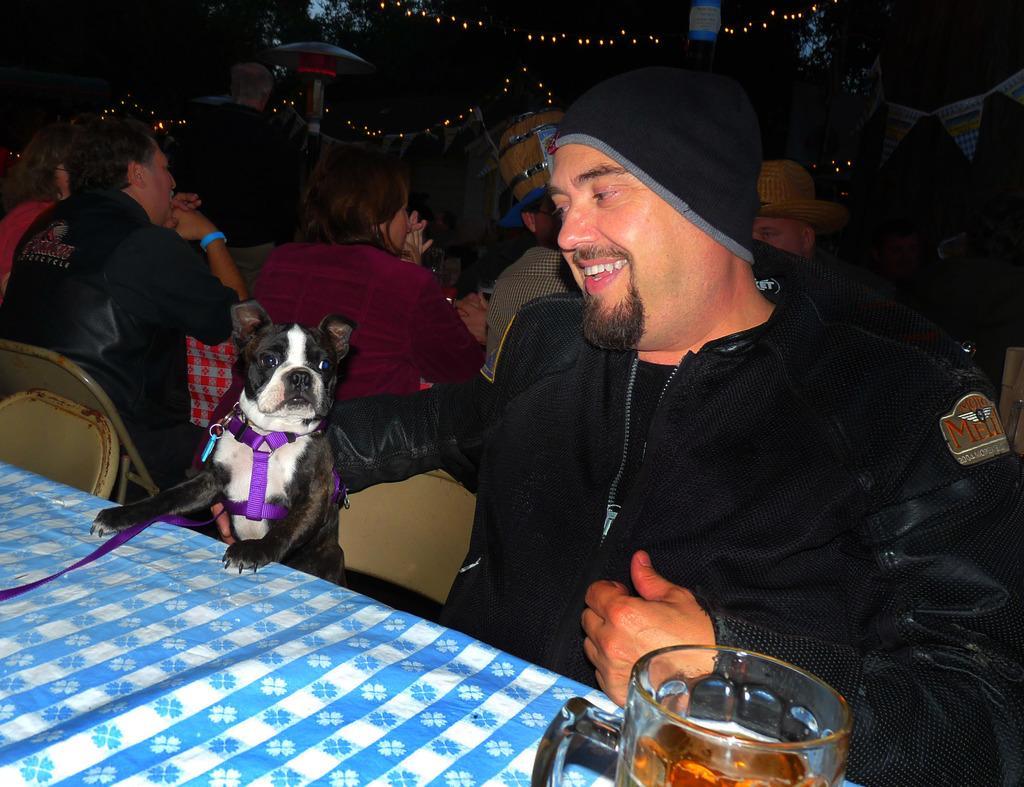Describe this image in one or two sentences. It seems to be the image is inside the restaurant. In the image there is a man holding a dog and sitting on chair in front of a table, on table we can see a glass. In background there are group of people sitting on chair and few lights. 